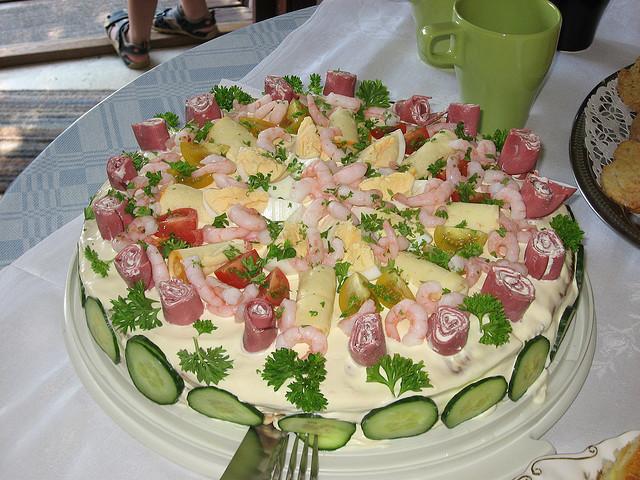What type of meal is this?
Answer briefly. Salad. Which utensil is on the table?
Short answer required. Fork. What is around the outside of the cake?
Answer briefly. Cucumbers. Is this a professional dish?
Concise answer only. Yes. Is this a dessert cake?
Answer briefly. No. Do you think this cake looks good?
Write a very short answer. Yes. 